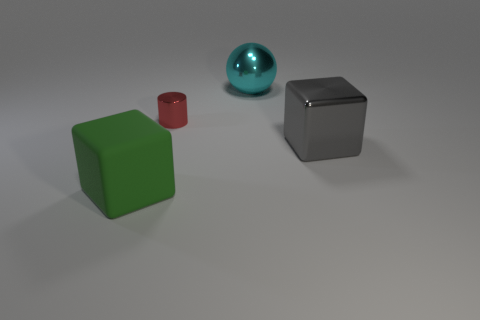Add 3 red shiny cylinders. How many objects exist? 7 Subtract all cylinders. How many objects are left? 3 Subtract all red blocks. Subtract all cyan cylinders. How many blocks are left? 2 Subtract all small metallic cylinders. Subtract all large matte cubes. How many objects are left? 2 Add 2 big cyan objects. How many big cyan objects are left? 3 Add 3 tiny purple metallic things. How many tiny purple metallic things exist? 3 Subtract 0 gray cylinders. How many objects are left? 4 